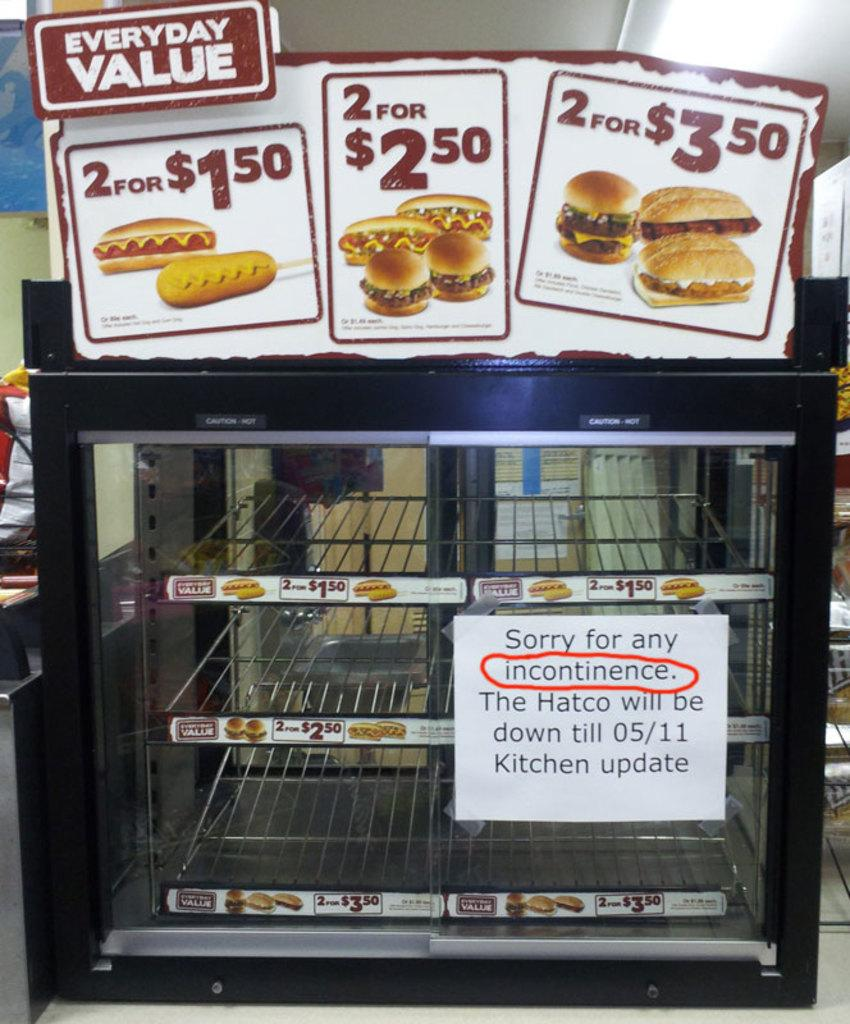Provide a one-sentence caption for the provided image. an empty display case with signs advertising everyday value. 